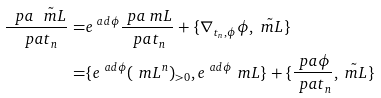Convert formula to latex. <formula><loc_0><loc_0><loc_500><loc_500>\frac { \ p a \tilde { \ m L } } { \ p a t _ { n } } = & e ^ { \ a d \phi } \frac { \ p a \ m L } { \ p a t _ { n } } + \{ \nabla _ { t _ { n } , \phi } \phi , \tilde { \ m L } \} \\ = & \{ e ^ { \ a d \phi } ( \ m L ^ { n } ) _ { > 0 } , e ^ { \ a d \phi } \ m L \} + \{ \frac { \ p a \phi } { \ p a t _ { n } } , \tilde { \ m L } \} \\</formula> 